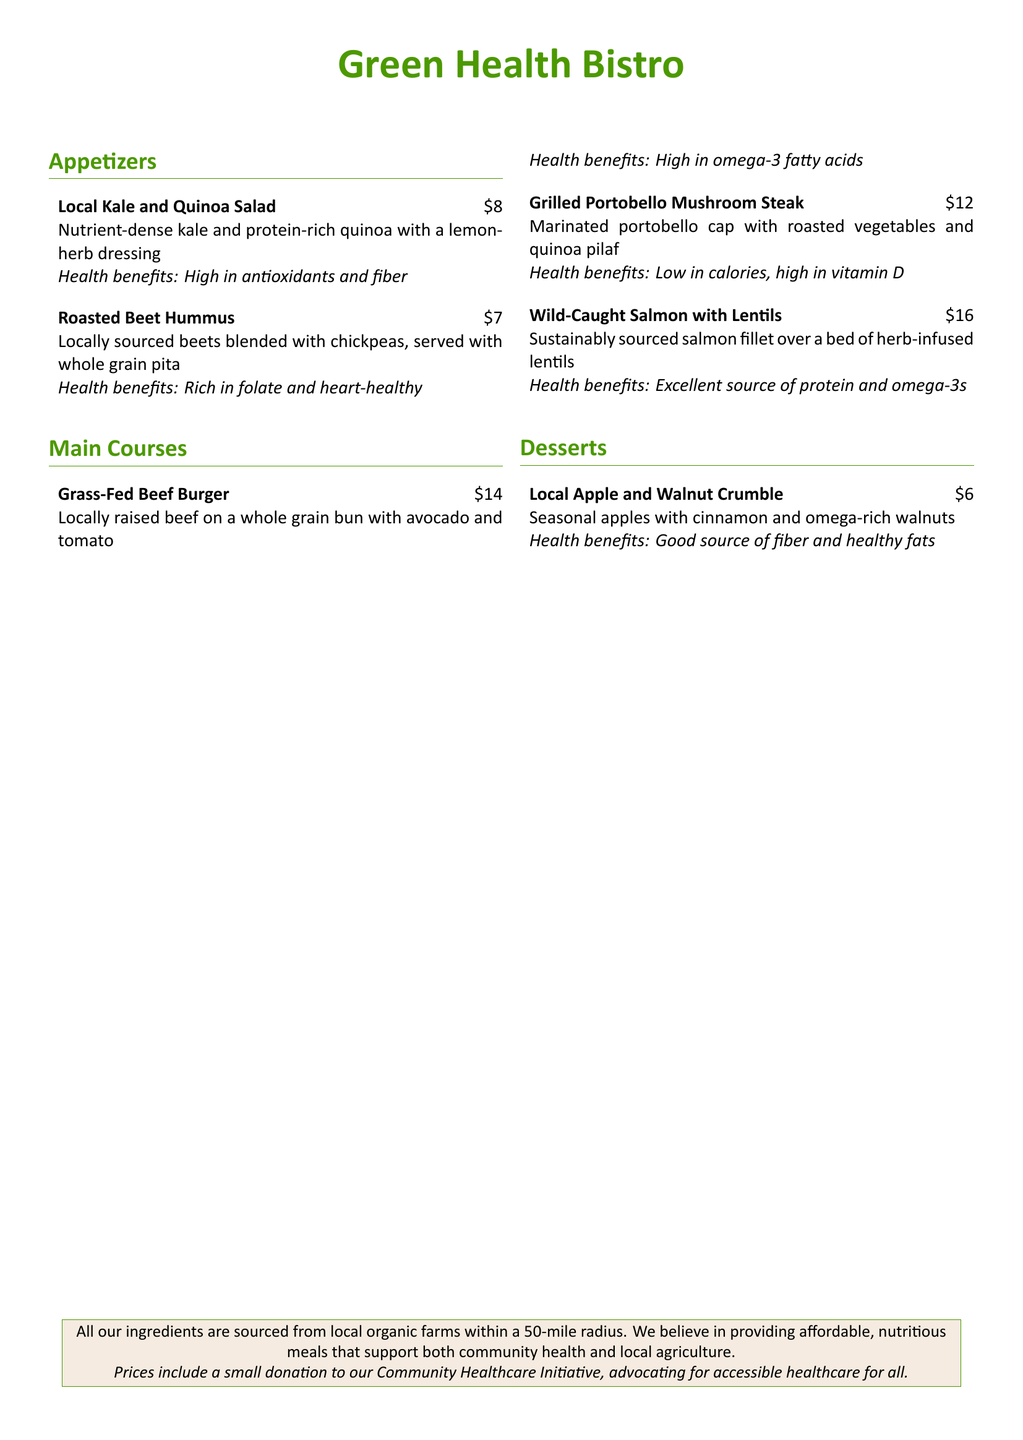What is the name of the restaurant? The restaurant's name is prominently displayed at the beginning of the menu.
Answer: Green Health Bistro How much does the Local Kale and Quinoa Salad cost? The cost of the salad is listed beside its name in the menu.
Answer: $8 What is a health benefit of the Roasted Beet Hummus? The health benefit is mentioned directly under the dish's description.
Answer: Rich in folate and heart-healthy What type of meat is used in the Grass-Fed Beef Burger? This information can be found in the description of the burger on the menu.
Answer: Beef What is served with the Wild-Caught Salmon? The menu states what the salmon is served over as part of its description.
Answer: Lentils How many appetizers are listed on the menu? The total number of appetizers can be counted from the menu section.
Answer: 2 What type of oil is a health benefit associated with the Grass-Fed Beef Burger? The health benefits mention specific fatty acids related to the dish.
Answer: Omega-3 fatty acids How much does the Local Apple and Walnut Crumble cost? The price is clearly stated alongside the dessert name in the menu.
Answer: $6 What is the initiative mentioned in the menu? The initiative is described in the footer of the menu.
Answer: Community Healthcare Initiative 